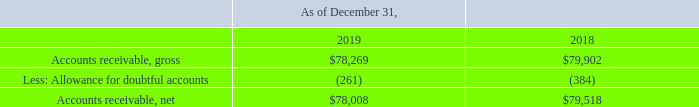NOTES TO CONSOLIDATED FINANCIAL STATEMENTS (in thousands, except for share and per share data)
NOTE 3 — Accounts Receivable
The components of accounts receivable are as follows:
Which years does the table provide information for the components of the accounts receivables for the company? 2019, 2018. What was the amount of gross accounts receivables in 2019?
Answer scale should be: thousand. 78,269. What was the amount of net accounts receivables in 2018?
Answer scale should be: thousand. 79,518. What was the change in gross accounts receivables between 2018 and 2019?
Answer scale should be: thousand. 78,269-79,902
Answer: -1633. How many years did net accounts receivables exceed $75,000 thousand? 2019##2018
Answer: 2. What was the percentage change in net accounts receivables between 2018 and 2019?
Answer scale should be: percent. (78,008-79,518)/79,518
Answer: -1.9. 